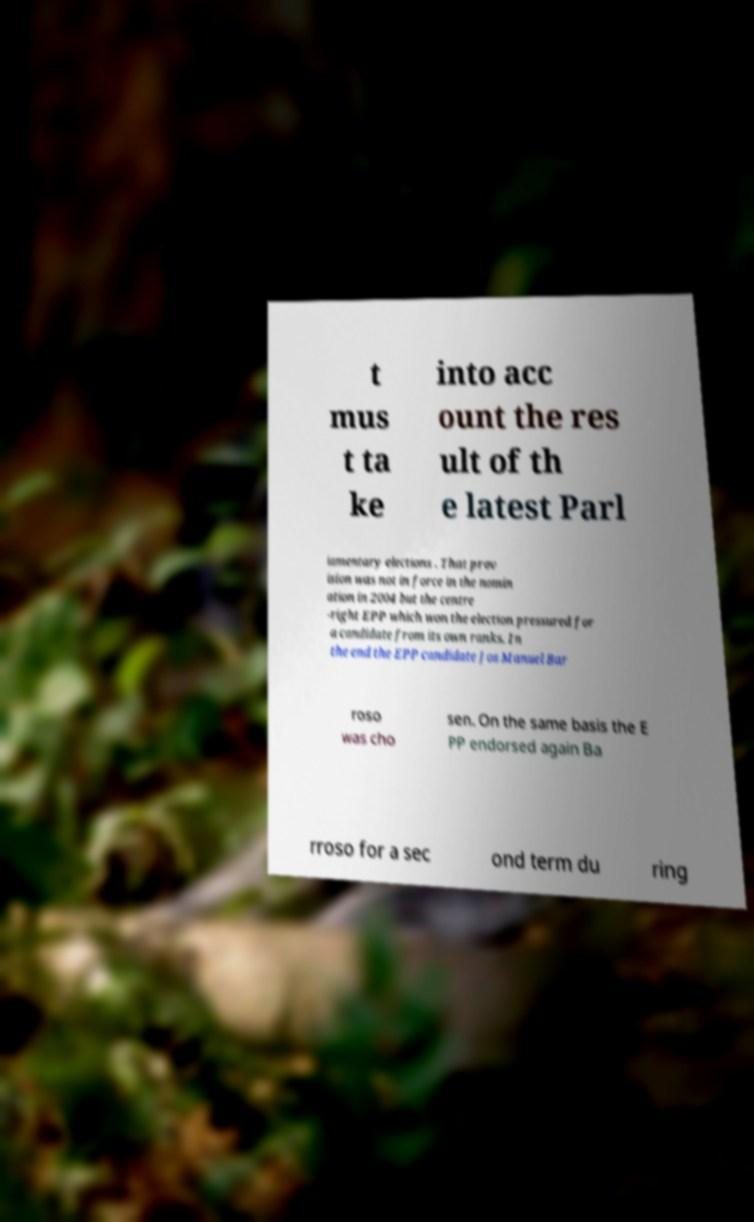I need the written content from this picture converted into text. Can you do that? t mus t ta ke into acc ount the res ult of th e latest Parl iamentary elections . That prov ision was not in force in the nomin ation in 2004 but the centre -right EPP which won the election pressured for a candidate from its own ranks. In the end the EPP candidate Jos Manuel Bar roso was cho sen. On the same basis the E PP endorsed again Ba rroso for a sec ond term du ring 